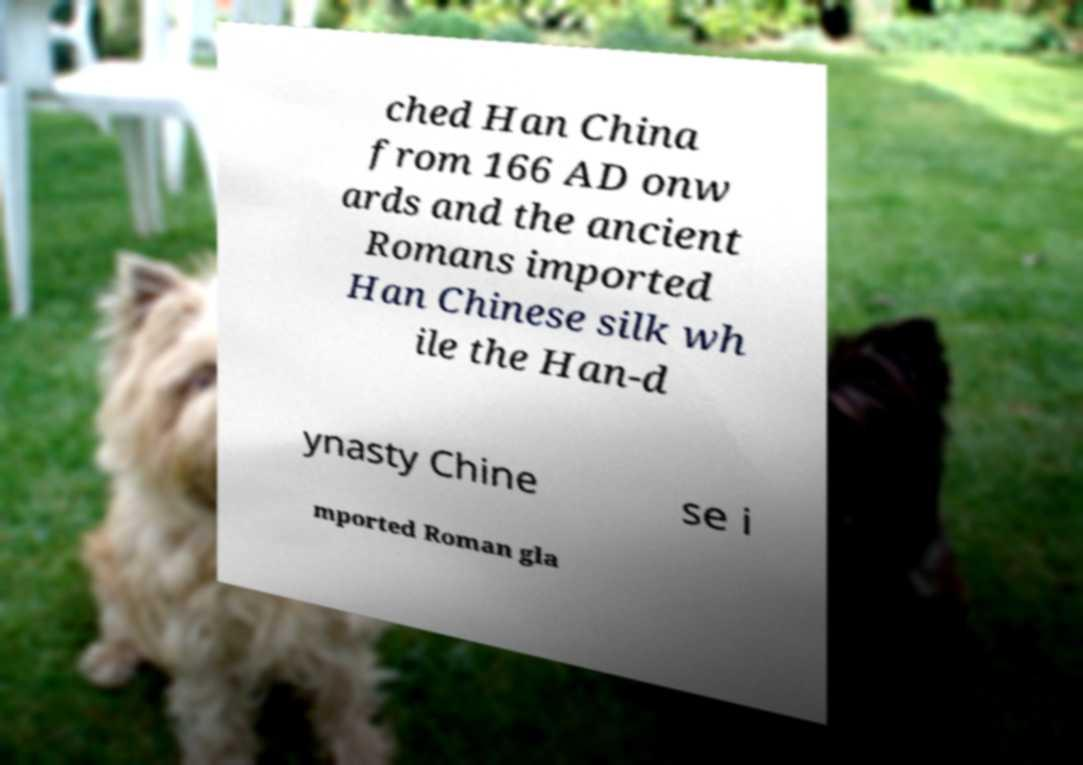There's text embedded in this image that I need extracted. Can you transcribe it verbatim? ched Han China from 166 AD onw ards and the ancient Romans imported Han Chinese silk wh ile the Han-d ynasty Chine se i mported Roman gla 